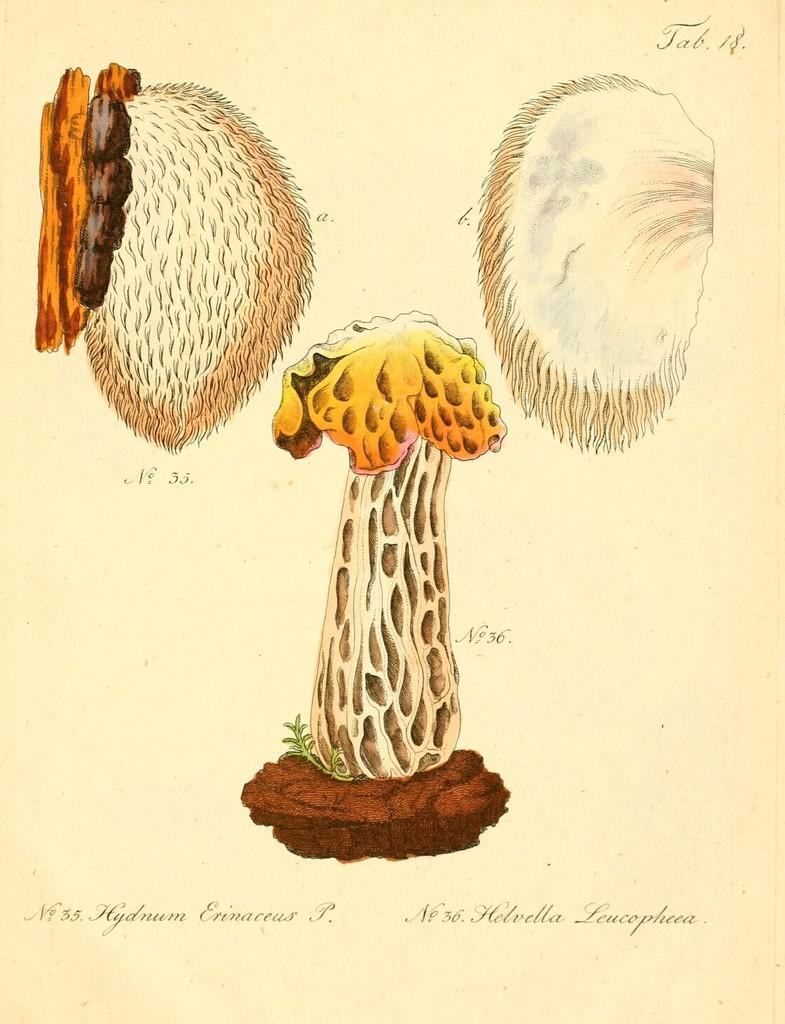What type of visual is the image? The image is a poster. What is the main subject of the poster? There is a depiction of a mushroom on the poster. Are there any other elements on the poster besides the mushroom? Yes, there are some objects on the poster. Is there any text present on the poster? Yes, there is text on the poster. What type of dress is the mushroom wearing in the image? The mushroom is not wearing a dress, as it is a non-living object and does not wear clothing. 